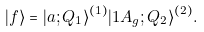Convert formula to latex. <formula><loc_0><loc_0><loc_500><loc_500>| f \rangle = | a ; Q _ { 1 } \rangle ^ { ( 1 ) } | 1 A _ { g } ; Q _ { 2 } \rangle ^ { ( 2 ) } .</formula> 